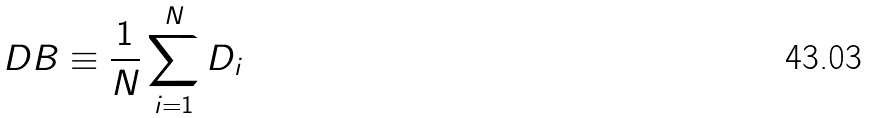<formula> <loc_0><loc_0><loc_500><loc_500>D B \equiv \frac { 1 } { N } \sum _ { i = 1 } ^ { N } D _ { i }</formula> 